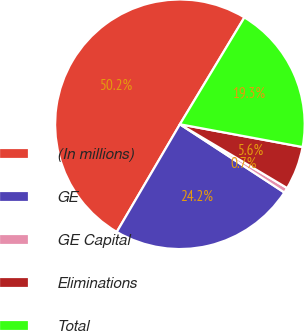Convert chart to OTSL. <chart><loc_0><loc_0><loc_500><loc_500><pie_chart><fcel>(In millions)<fcel>GE<fcel>GE Capital<fcel>Eliminations<fcel>Total<nl><fcel>50.2%<fcel>24.23%<fcel>0.67%<fcel>5.62%<fcel>19.28%<nl></chart> 